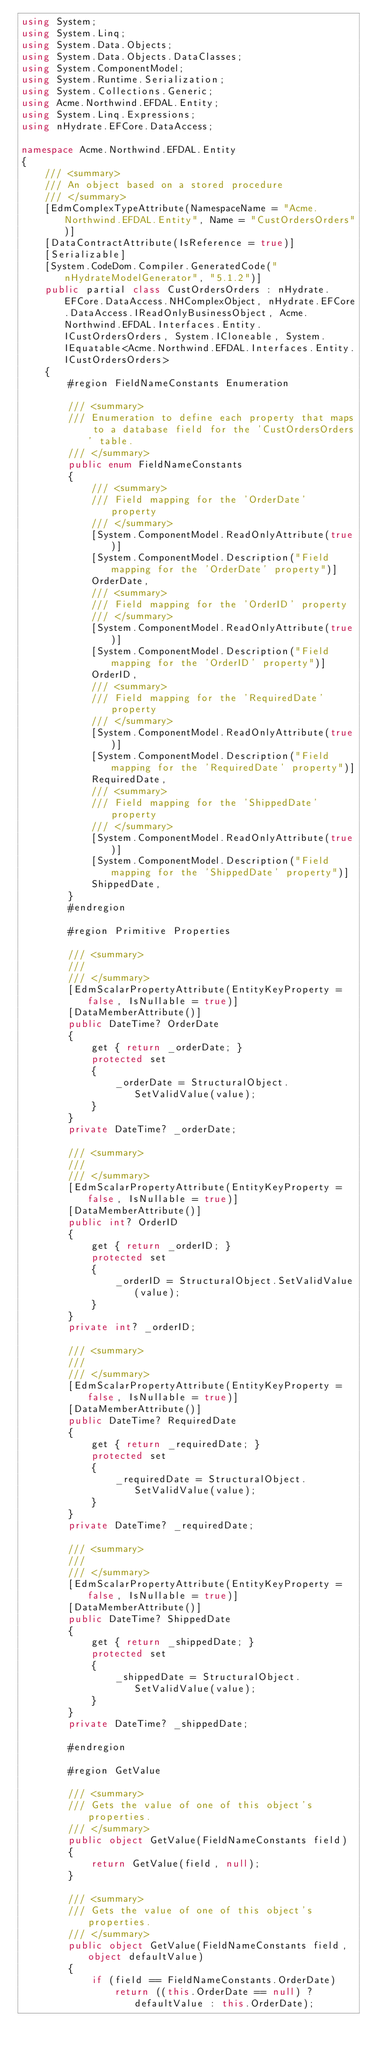<code> <loc_0><loc_0><loc_500><loc_500><_C#_>using System;
using System.Linq;
using System.Data.Objects;
using System.Data.Objects.DataClasses;
using System.ComponentModel;
using System.Runtime.Serialization;
using System.Collections.Generic;
using Acme.Northwind.EFDAL.Entity;
using System.Linq.Expressions;
using nHydrate.EFCore.DataAccess;

namespace Acme.Northwind.EFDAL.Entity
{
	/// <summary>
	/// An object based on a stored procedure
	/// </summary>
	[EdmComplexTypeAttribute(NamespaceName = "Acme.Northwind.EFDAL.Entity", Name = "CustOrdersOrders")]
	[DataContractAttribute(IsReference = true)]
	[Serializable]
	[System.CodeDom.Compiler.GeneratedCode("nHydrateModelGenerator", "5.1.2")]
	public partial class CustOrdersOrders : nHydrate.EFCore.DataAccess.NHComplexObject, nHydrate.EFCore.DataAccess.IReadOnlyBusinessObject, Acme.Northwind.EFDAL.Interfaces.Entity.ICustOrdersOrders, System.ICloneable, System.IEquatable<Acme.Northwind.EFDAL.Interfaces.Entity.ICustOrdersOrders>
	{
		#region FieldNameConstants Enumeration

		/// <summary>
		/// Enumeration to define each property that maps to a database field for the 'CustOrdersOrders' table.
		/// </summary>
		public enum FieldNameConstants
		{
			/// <summary>
			/// Field mapping for the 'OrderDate' property
			/// </summary>
			[System.ComponentModel.ReadOnlyAttribute(true)]
			[System.ComponentModel.Description("Field mapping for the 'OrderDate' property")]
			OrderDate,
			/// <summary>
			/// Field mapping for the 'OrderID' property
			/// </summary>
			[System.ComponentModel.ReadOnlyAttribute(true)]
			[System.ComponentModel.Description("Field mapping for the 'OrderID' property")]
			OrderID,
			/// <summary>
			/// Field mapping for the 'RequiredDate' property
			/// </summary>
			[System.ComponentModel.ReadOnlyAttribute(true)]
			[System.ComponentModel.Description("Field mapping for the 'RequiredDate' property")]
			RequiredDate,
			/// <summary>
			/// Field mapping for the 'ShippedDate' property
			/// </summary>
			[System.ComponentModel.ReadOnlyAttribute(true)]
			[System.ComponentModel.Description("Field mapping for the 'ShippedDate' property")]
			ShippedDate,
		}
		#endregion

		#region Primitive Properties

		/// <summary>
		/// 
		/// </summary>
		[EdmScalarPropertyAttribute(EntityKeyProperty = false, IsNullable = true)]
		[DataMemberAttribute()]
		public DateTime? OrderDate
		{
			get { return _orderDate; }
			protected set
			{
				_orderDate = StructuralObject.SetValidValue(value);
			}
		}
		private DateTime? _orderDate;

		/// <summary>
		/// 
		/// </summary>
		[EdmScalarPropertyAttribute(EntityKeyProperty = false, IsNullable = true)]
		[DataMemberAttribute()]
		public int? OrderID
		{
			get { return _orderID; }
			protected set
			{
				_orderID = StructuralObject.SetValidValue(value);
			}
		}
		private int? _orderID;

		/// <summary>
		/// 
		/// </summary>
		[EdmScalarPropertyAttribute(EntityKeyProperty = false, IsNullable = true)]
		[DataMemberAttribute()]
		public DateTime? RequiredDate
		{
			get { return _requiredDate; }
			protected set
			{
				_requiredDate = StructuralObject.SetValidValue(value);
			}
		}
		private DateTime? _requiredDate;

		/// <summary>
		/// 
		/// </summary>
		[EdmScalarPropertyAttribute(EntityKeyProperty = false, IsNullable = true)]
		[DataMemberAttribute()]
		public DateTime? ShippedDate
		{
			get { return _shippedDate; }
			protected set
			{
				_shippedDate = StructuralObject.SetValidValue(value);
			}
		}
		private DateTime? _shippedDate;

		#endregion

		#region GetValue

		/// <summary>
		/// Gets the value of one of this object's properties.
		/// </summary>
		public object GetValue(FieldNameConstants field)
		{
			return GetValue(field, null);
		}

		/// <summary>
		/// Gets the value of one of this object's properties.
		/// </summary>
		public object GetValue(FieldNameConstants field, object defaultValue)
		{
			if (field == FieldNameConstants.OrderDate)
				return ((this.OrderDate == null) ? defaultValue : this.OrderDate);</code> 